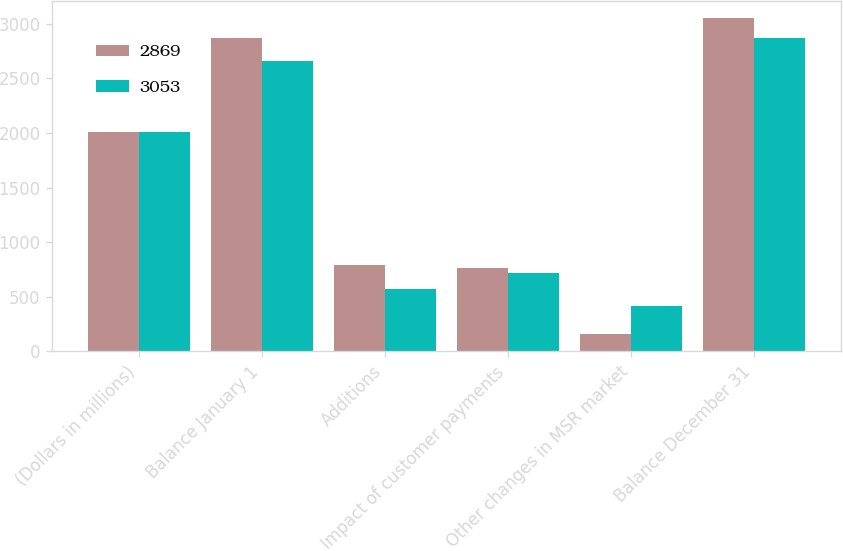Convert chart. <chart><loc_0><loc_0><loc_500><loc_500><stacked_bar_chart><ecel><fcel>(Dollars in millions)<fcel>Balance January 1<fcel>Additions<fcel>Impact of customer payments<fcel>Other changes in MSR market<fcel>Balance December 31<nl><fcel>2869<fcel>2007<fcel>2869<fcel>792<fcel>766<fcel>158<fcel>3053<nl><fcel>3053<fcel>2006<fcel>2658<fcel>572<fcel>713<fcel>414<fcel>2869<nl></chart> 